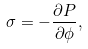Convert formula to latex. <formula><loc_0><loc_0><loc_500><loc_500>\sigma = - \frac { \partial P } { \partial \phi } ,</formula> 